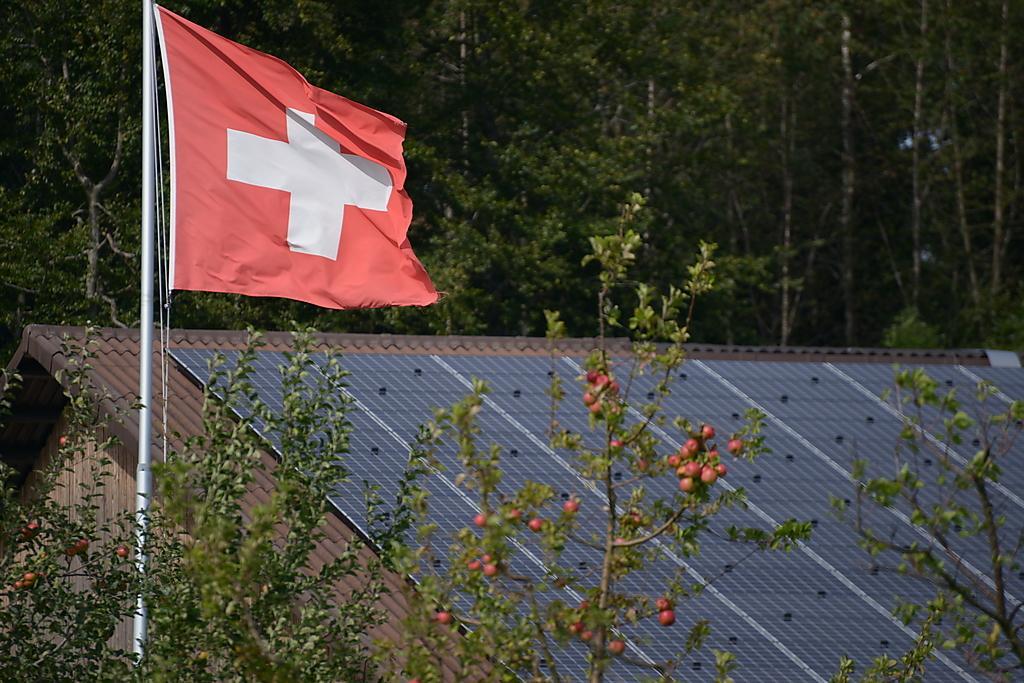Please provide a concise description of this image. In this image we can see a house, there are some trees and fruits, also we can see a flag to the pole. 